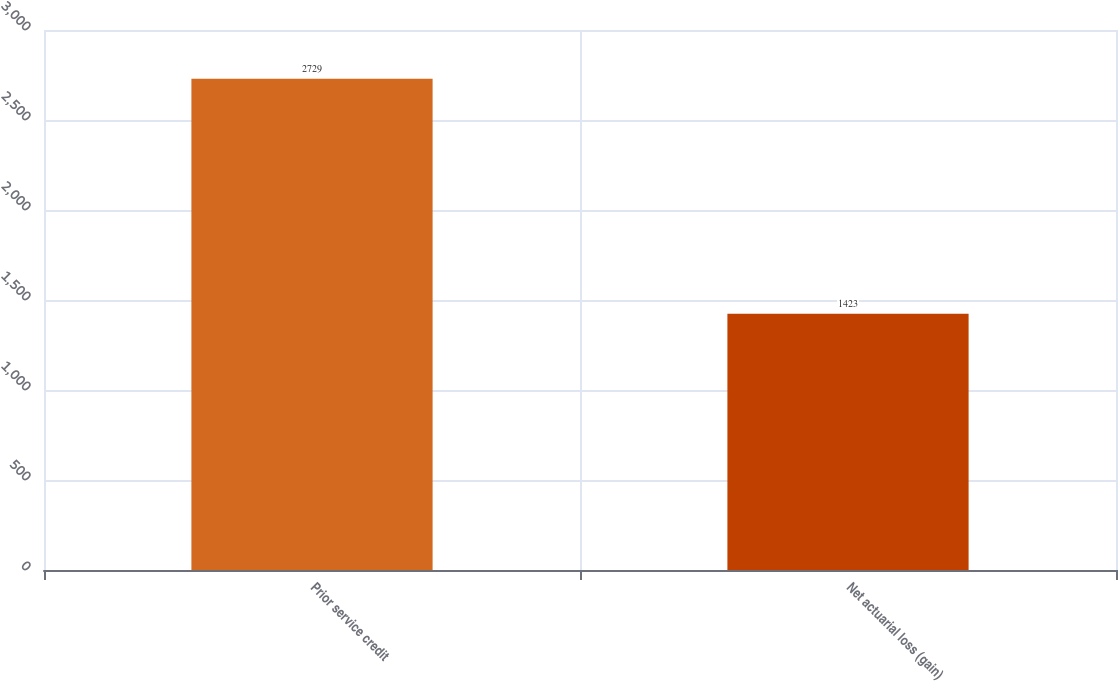<chart> <loc_0><loc_0><loc_500><loc_500><bar_chart><fcel>Prior service credit<fcel>Net actuarial loss (gain)<nl><fcel>2729<fcel>1423<nl></chart> 